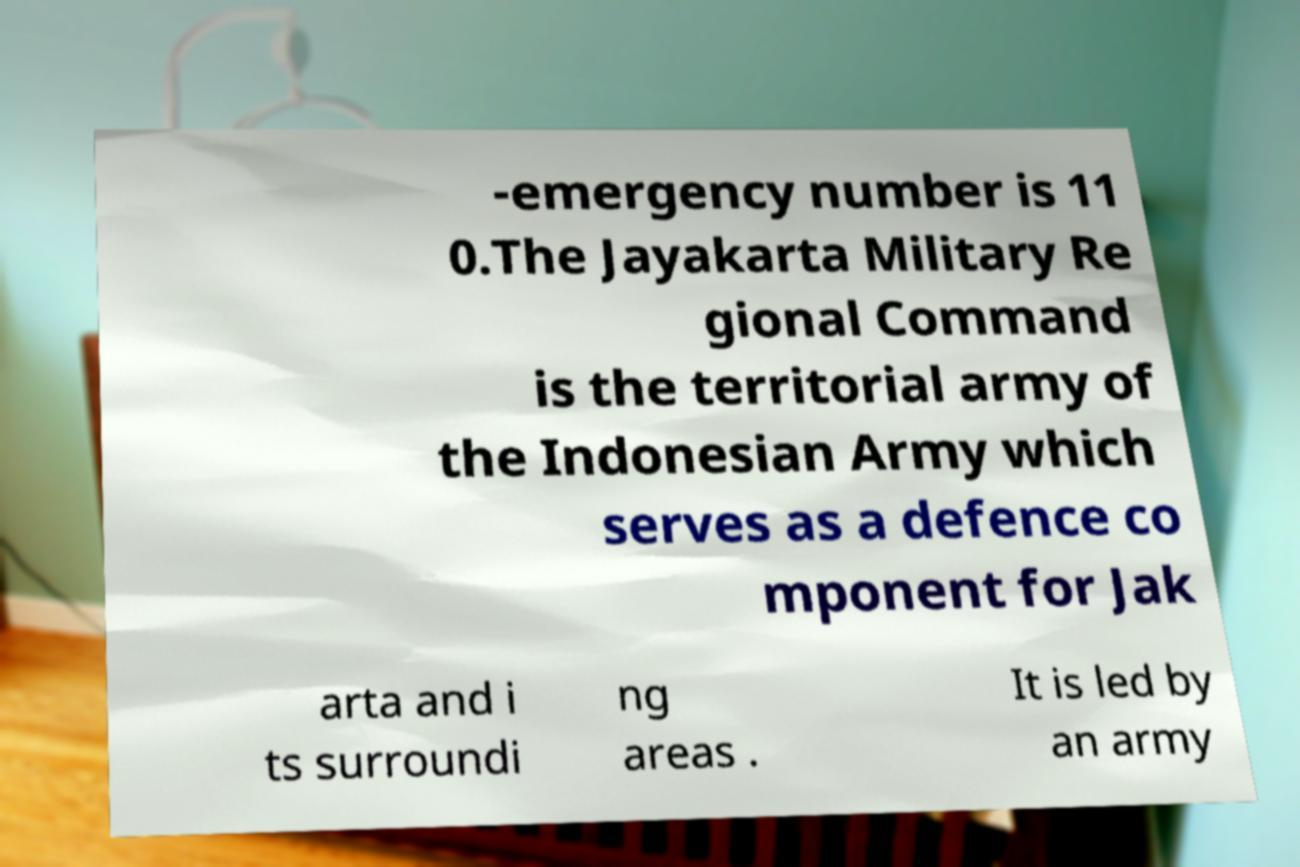Please identify and transcribe the text found in this image. -emergency number is 11 0.The Jayakarta Military Re gional Command is the territorial army of the Indonesian Army which serves as a defence co mponent for Jak arta and i ts surroundi ng areas . It is led by an army 